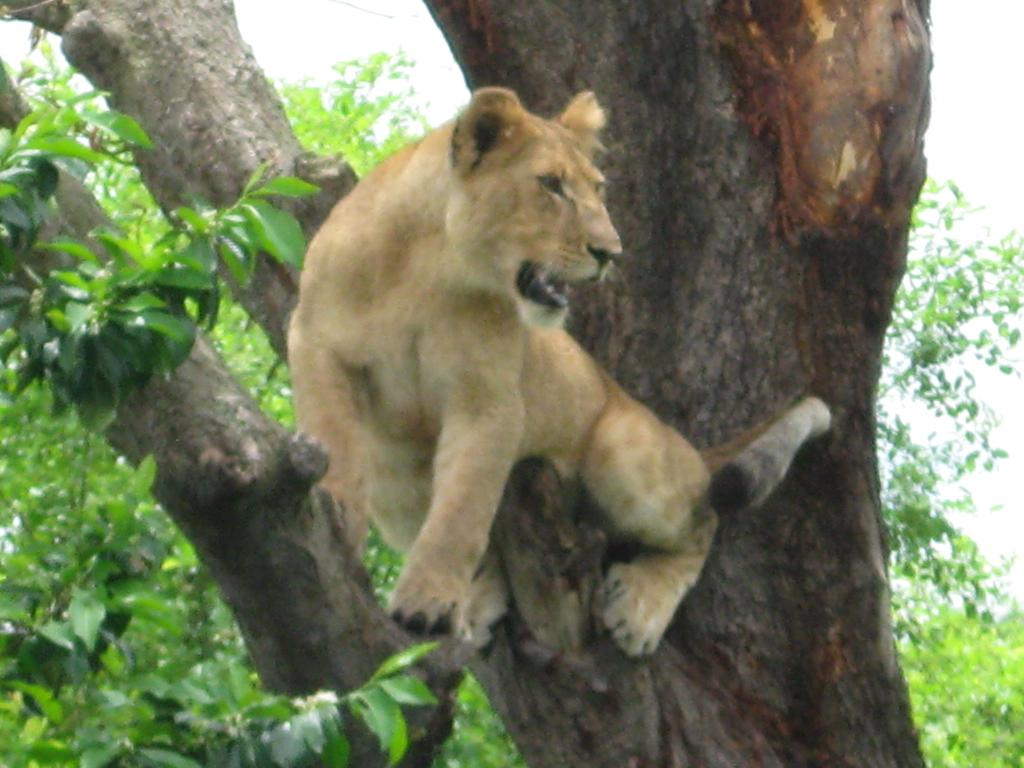What animal is in the foreground of the image? There is a lion in the foreground of the image. Where is the lion located? The lion is on a tree. What can be seen in the background of the image? The sky is visible in the background of the image. What type of wire is being used by the lion to climb the tree in the image? There is no wire present in the image; the lion is climbing the tree without any visible assistance. 